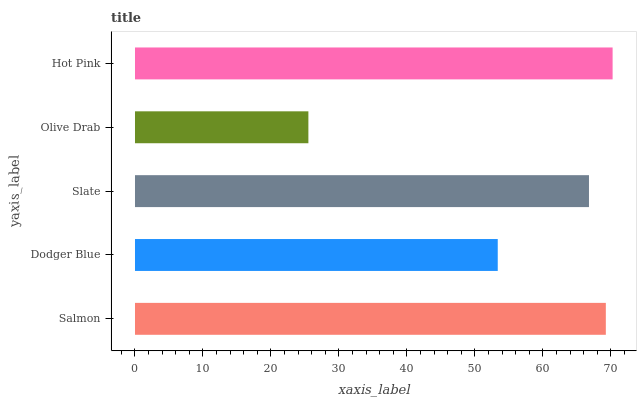Is Olive Drab the minimum?
Answer yes or no. Yes. Is Hot Pink the maximum?
Answer yes or no. Yes. Is Dodger Blue the minimum?
Answer yes or no. No. Is Dodger Blue the maximum?
Answer yes or no. No. Is Salmon greater than Dodger Blue?
Answer yes or no. Yes. Is Dodger Blue less than Salmon?
Answer yes or no. Yes. Is Dodger Blue greater than Salmon?
Answer yes or no. No. Is Salmon less than Dodger Blue?
Answer yes or no. No. Is Slate the high median?
Answer yes or no. Yes. Is Slate the low median?
Answer yes or no. Yes. Is Salmon the high median?
Answer yes or no. No. Is Dodger Blue the low median?
Answer yes or no. No. 